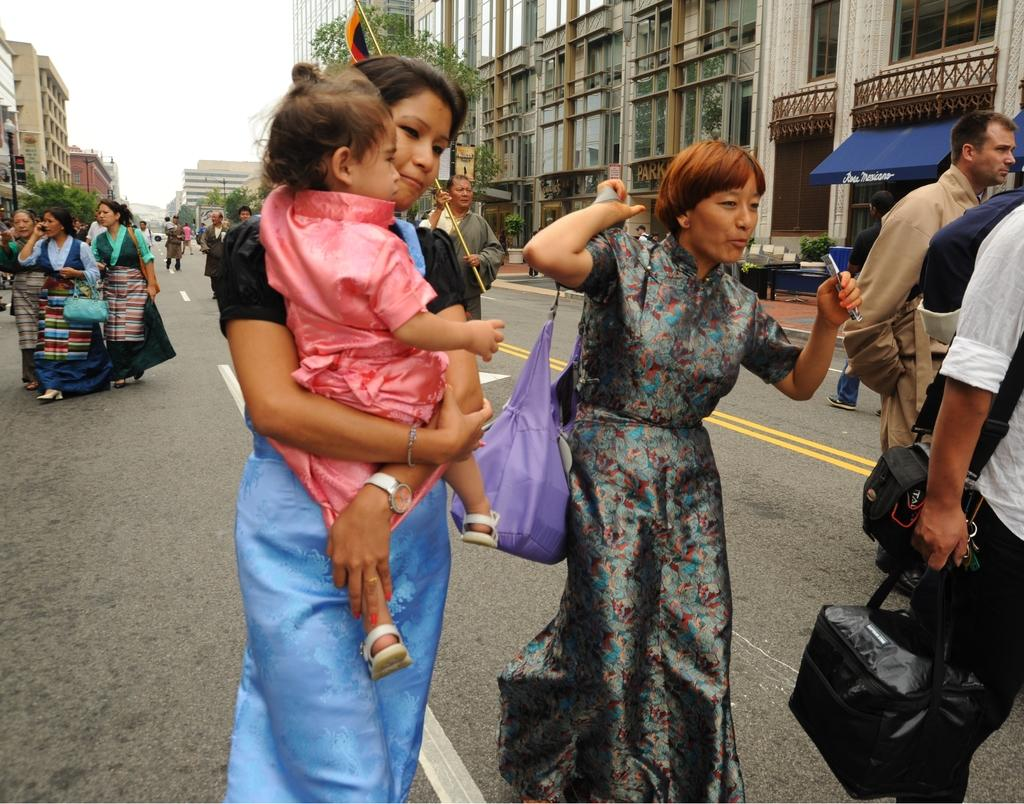What is happening on the road in the image? There are people on the road in the image. What can be seen in the background of the image? There are buildings visible in the image. Are there any natural elements present in the image? Yes, there are trees in the image. Can you hear the hen laughing in the image? There is no hen or laughter present in the image; it only shows people on the road, buildings, and trees. 